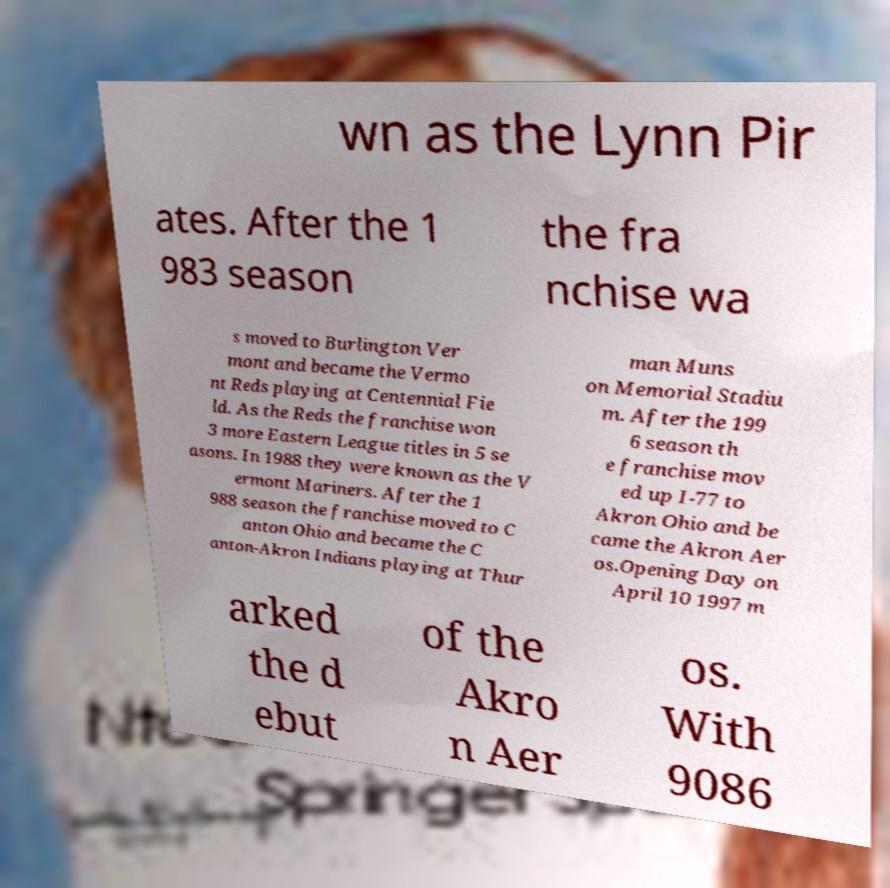Please read and relay the text visible in this image. What does it say? wn as the Lynn Pir ates. After the 1 983 season the fra nchise wa s moved to Burlington Ver mont and became the Vermo nt Reds playing at Centennial Fie ld. As the Reds the franchise won 3 more Eastern League titles in 5 se asons. In 1988 they were known as the V ermont Mariners. After the 1 988 season the franchise moved to C anton Ohio and became the C anton-Akron Indians playing at Thur man Muns on Memorial Stadiu m. After the 199 6 season th e franchise mov ed up I-77 to Akron Ohio and be came the Akron Aer os.Opening Day on April 10 1997 m arked the d ebut of the Akro n Aer os. With 9086 